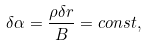Convert formula to latex. <formula><loc_0><loc_0><loc_500><loc_500>\delta \alpha = \frac { \rho \delta { r } } { B } = c o n s t ,</formula> 